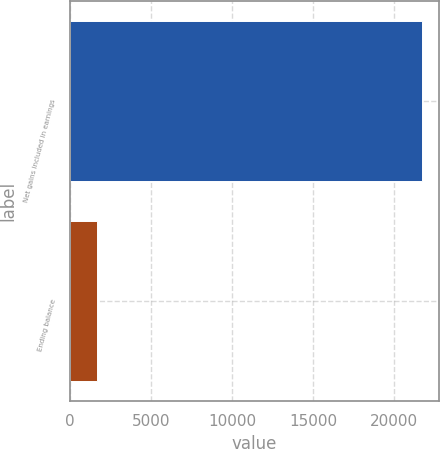Convert chart to OTSL. <chart><loc_0><loc_0><loc_500><loc_500><bar_chart><fcel>Net gains included in earnings<fcel>Ending balance<nl><fcel>21709<fcel>1680<nl></chart> 